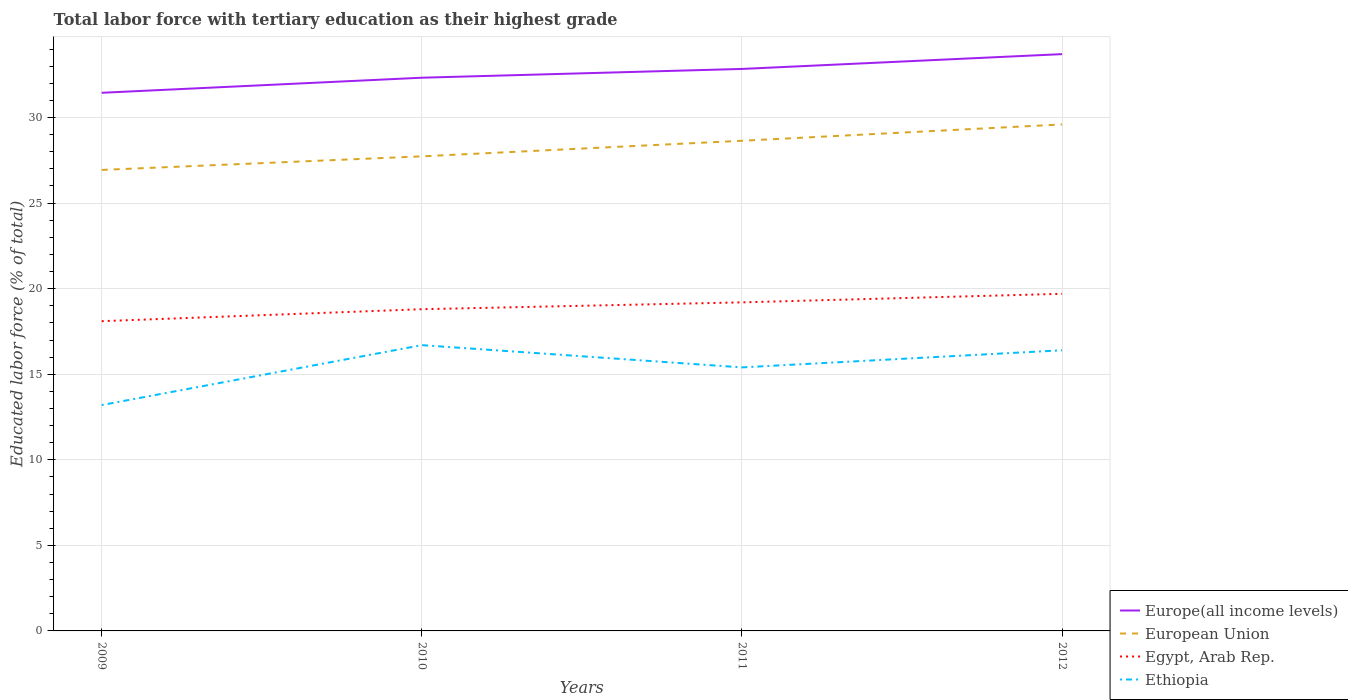How many different coloured lines are there?
Your answer should be very brief. 4. Is the number of lines equal to the number of legend labels?
Give a very brief answer. Yes. Across all years, what is the maximum percentage of male labor force with tertiary education in European Union?
Provide a succinct answer. 26.94. What is the total percentage of male labor force with tertiary education in Egypt, Arab Rep. in the graph?
Offer a terse response. -0.4. What is the difference between the highest and the second highest percentage of male labor force with tertiary education in European Union?
Give a very brief answer. 2.66. Is the percentage of male labor force with tertiary education in European Union strictly greater than the percentage of male labor force with tertiary education in Europe(all income levels) over the years?
Make the answer very short. Yes. How many years are there in the graph?
Offer a terse response. 4. Are the values on the major ticks of Y-axis written in scientific E-notation?
Offer a terse response. No. Does the graph contain grids?
Make the answer very short. Yes. What is the title of the graph?
Provide a short and direct response. Total labor force with tertiary education as their highest grade. What is the label or title of the Y-axis?
Your answer should be compact. Educated labor force (% of total). What is the Educated labor force (% of total) in Europe(all income levels) in 2009?
Keep it short and to the point. 31.45. What is the Educated labor force (% of total) of European Union in 2009?
Provide a succinct answer. 26.94. What is the Educated labor force (% of total) in Egypt, Arab Rep. in 2009?
Ensure brevity in your answer.  18.1. What is the Educated labor force (% of total) in Ethiopia in 2009?
Your response must be concise. 13.2. What is the Educated labor force (% of total) in Europe(all income levels) in 2010?
Keep it short and to the point. 32.33. What is the Educated labor force (% of total) in European Union in 2010?
Your answer should be compact. 27.73. What is the Educated labor force (% of total) in Egypt, Arab Rep. in 2010?
Your answer should be compact. 18.8. What is the Educated labor force (% of total) in Ethiopia in 2010?
Give a very brief answer. 16.7. What is the Educated labor force (% of total) of Europe(all income levels) in 2011?
Keep it short and to the point. 32.84. What is the Educated labor force (% of total) of European Union in 2011?
Make the answer very short. 28.64. What is the Educated labor force (% of total) in Egypt, Arab Rep. in 2011?
Offer a very short reply. 19.2. What is the Educated labor force (% of total) of Ethiopia in 2011?
Your answer should be very brief. 15.4. What is the Educated labor force (% of total) in Europe(all income levels) in 2012?
Make the answer very short. 33.71. What is the Educated labor force (% of total) in European Union in 2012?
Offer a terse response. 29.6. What is the Educated labor force (% of total) in Egypt, Arab Rep. in 2012?
Make the answer very short. 19.7. What is the Educated labor force (% of total) of Ethiopia in 2012?
Keep it short and to the point. 16.4. Across all years, what is the maximum Educated labor force (% of total) of Europe(all income levels)?
Your answer should be very brief. 33.71. Across all years, what is the maximum Educated labor force (% of total) of European Union?
Your response must be concise. 29.6. Across all years, what is the maximum Educated labor force (% of total) in Egypt, Arab Rep.?
Give a very brief answer. 19.7. Across all years, what is the maximum Educated labor force (% of total) in Ethiopia?
Your answer should be compact. 16.7. Across all years, what is the minimum Educated labor force (% of total) of Europe(all income levels)?
Provide a succinct answer. 31.45. Across all years, what is the minimum Educated labor force (% of total) of European Union?
Provide a short and direct response. 26.94. Across all years, what is the minimum Educated labor force (% of total) in Egypt, Arab Rep.?
Give a very brief answer. 18.1. Across all years, what is the minimum Educated labor force (% of total) in Ethiopia?
Offer a very short reply. 13.2. What is the total Educated labor force (% of total) in Europe(all income levels) in the graph?
Provide a succinct answer. 130.32. What is the total Educated labor force (% of total) of European Union in the graph?
Your answer should be very brief. 112.91. What is the total Educated labor force (% of total) in Egypt, Arab Rep. in the graph?
Provide a succinct answer. 75.8. What is the total Educated labor force (% of total) in Ethiopia in the graph?
Give a very brief answer. 61.7. What is the difference between the Educated labor force (% of total) in Europe(all income levels) in 2009 and that in 2010?
Your answer should be compact. -0.88. What is the difference between the Educated labor force (% of total) of European Union in 2009 and that in 2010?
Ensure brevity in your answer.  -0.79. What is the difference between the Educated labor force (% of total) of Egypt, Arab Rep. in 2009 and that in 2010?
Your answer should be very brief. -0.7. What is the difference between the Educated labor force (% of total) in Europe(all income levels) in 2009 and that in 2011?
Offer a terse response. -1.39. What is the difference between the Educated labor force (% of total) in European Union in 2009 and that in 2011?
Give a very brief answer. -1.7. What is the difference between the Educated labor force (% of total) of Egypt, Arab Rep. in 2009 and that in 2011?
Provide a succinct answer. -1.1. What is the difference between the Educated labor force (% of total) of Europe(all income levels) in 2009 and that in 2012?
Provide a short and direct response. -2.26. What is the difference between the Educated labor force (% of total) of European Union in 2009 and that in 2012?
Make the answer very short. -2.66. What is the difference between the Educated labor force (% of total) in Egypt, Arab Rep. in 2009 and that in 2012?
Make the answer very short. -1.6. What is the difference between the Educated labor force (% of total) in Europe(all income levels) in 2010 and that in 2011?
Keep it short and to the point. -0.51. What is the difference between the Educated labor force (% of total) in European Union in 2010 and that in 2011?
Provide a short and direct response. -0.91. What is the difference between the Educated labor force (% of total) of Egypt, Arab Rep. in 2010 and that in 2011?
Provide a short and direct response. -0.4. What is the difference between the Educated labor force (% of total) in Europe(all income levels) in 2010 and that in 2012?
Offer a terse response. -1.38. What is the difference between the Educated labor force (% of total) of European Union in 2010 and that in 2012?
Your answer should be compact. -1.86. What is the difference between the Educated labor force (% of total) of Egypt, Arab Rep. in 2010 and that in 2012?
Keep it short and to the point. -0.9. What is the difference between the Educated labor force (% of total) of Europe(all income levels) in 2011 and that in 2012?
Provide a succinct answer. -0.87. What is the difference between the Educated labor force (% of total) of European Union in 2011 and that in 2012?
Offer a very short reply. -0.95. What is the difference between the Educated labor force (% of total) of Ethiopia in 2011 and that in 2012?
Ensure brevity in your answer.  -1. What is the difference between the Educated labor force (% of total) in Europe(all income levels) in 2009 and the Educated labor force (% of total) in European Union in 2010?
Provide a short and direct response. 3.71. What is the difference between the Educated labor force (% of total) in Europe(all income levels) in 2009 and the Educated labor force (% of total) in Egypt, Arab Rep. in 2010?
Your response must be concise. 12.65. What is the difference between the Educated labor force (% of total) of Europe(all income levels) in 2009 and the Educated labor force (% of total) of Ethiopia in 2010?
Your response must be concise. 14.75. What is the difference between the Educated labor force (% of total) of European Union in 2009 and the Educated labor force (% of total) of Egypt, Arab Rep. in 2010?
Provide a succinct answer. 8.14. What is the difference between the Educated labor force (% of total) in European Union in 2009 and the Educated labor force (% of total) in Ethiopia in 2010?
Provide a succinct answer. 10.24. What is the difference between the Educated labor force (% of total) of Europe(all income levels) in 2009 and the Educated labor force (% of total) of European Union in 2011?
Give a very brief answer. 2.8. What is the difference between the Educated labor force (% of total) of Europe(all income levels) in 2009 and the Educated labor force (% of total) of Egypt, Arab Rep. in 2011?
Make the answer very short. 12.25. What is the difference between the Educated labor force (% of total) of Europe(all income levels) in 2009 and the Educated labor force (% of total) of Ethiopia in 2011?
Your answer should be compact. 16.05. What is the difference between the Educated labor force (% of total) of European Union in 2009 and the Educated labor force (% of total) of Egypt, Arab Rep. in 2011?
Offer a very short reply. 7.74. What is the difference between the Educated labor force (% of total) of European Union in 2009 and the Educated labor force (% of total) of Ethiopia in 2011?
Keep it short and to the point. 11.54. What is the difference between the Educated labor force (% of total) in Europe(all income levels) in 2009 and the Educated labor force (% of total) in European Union in 2012?
Offer a terse response. 1.85. What is the difference between the Educated labor force (% of total) in Europe(all income levels) in 2009 and the Educated labor force (% of total) in Egypt, Arab Rep. in 2012?
Keep it short and to the point. 11.75. What is the difference between the Educated labor force (% of total) in Europe(all income levels) in 2009 and the Educated labor force (% of total) in Ethiopia in 2012?
Make the answer very short. 15.05. What is the difference between the Educated labor force (% of total) of European Union in 2009 and the Educated labor force (% of total) of Egypt, Arab Rep. in 2012?
Make the answer very short. 7.24. What is the difference between the Educated labor force (% of total) in European Union in 2009 and the Educated labor force (% of total) in Ethiopia in 2012?
Give a very brief answer. 10.54. What is the difference between the Educated labor force (% of total) of Europe(all income levels) in 2010 and the Educated labor force (% of total) of European Union in 2011?
Offer a very short reply. 3.68. What is the difference between the Educated labor force (% of total) of Europe(all income levels) in 2010 and the Educated labor force (% of total) of Egypt, Arab Rep. in 2011?
Offer a terse response. 13.13. What is the difference between the Educated labor force (% of total) in Europe(all income levels) in 2010 and the Educated labor force (% of total) in Ethiopia in 2011?
Ensure brevity in your answer.  16.93. What is the difference between the Educated labor force (% of total) of European Union in 2010 and the Educated labor force (% of total) of Egypt, Arab Rep. in 2011?
Ensure brevity in your answer.  8.53. What is the difference between the Educated labor force (% of total) of European Union in 2010 and the Educated labor force (% of total) of Ethiopia in 2011?
Ensure brevity in your answer.  12.33. What is the difference between the Educated labor force (% of total) of Egypt, Arab Rep. in 2010 and the Educated labor force (% of total) of Ethiopia in 2011?
Offer a terse response. 3.4. What is the difference between the Educated labor force (% of total) in Europe(all income levels) in 2010 and the Educated labor force (% of total) in European Union in 2012?
Your answer should be compact. 2.73. What is the difference between the Educated labor force (% of total) in Europe(all income levels) in 2010 and the Educated labor force (% of total) in Egypt, Arab Rep. in 2012?
Offer a terse response. 12.63. What is the difference between the Educated labor force (% of total) of Europe(all income levels) in 2010 and the Educated labor force (% of total) of Ethiopia in 2012?
Your answer should be very brief. 15.93. What is the difference between the Educated labor force (% of total) of European Union in 2010 and the Educated labor force (% of total) of Egypt, Arab Rep. in 2012?
Offer a very short reply. 8.03. What is the difference between the Educated labor force (% of total) of European Union in 2010 and the Educated labor force (% of total) of Ethiopia in 2012?
Give a very brief answer. 11.33. What is the difference between the Educated labor force (% of total) of Egypt, Arab Rep. in 2010 and the Educated labor force (% of total) of Ethiopia in 2012?
Offer a very short reply. 2.4. What is the difference between the Educated labor force (% of total) in Europe(all income levels) in 2011 and the Educated labor force (% of total) in European Union in 2012?
Offer a terse response. 3.24. What is the difference between the Educated labor force (% of total) of Europe(all income levels) in 2011 and the Educated labor force (% of total) of Egypt, Arab Rep. in 2012?
Ensure brevity in your answer.  13.14. What is the difference between the Educated labor force (% of total) in Europe(all income levels) in 2011 and the Educated labor force (% of total) in Ethiopia in 2012?
Your response must be concise. 16.44. What is the difference between the Educated labor force (% of total) of European Union in 2011 and the Educated labor force (% of total) of Egypt, Arab Rep. in 2012?
Your answer should be very brief. 8.94. What is the difference between the Educated labor force (% of total) of European Union in 2011 and the Educated labor force (% of total) of Ethiopia in 2012?
Your answer should be compact. 12.24. What is the difference between the Educated labor force (% of total) in Egypt, Arab Rep. in 2011 and the Educated labor force (% of total) in Ethiopia in 2012?
Give a very brief answer. 2.8. What is the average Educated labor force (% of total) in Europe(all income levels) per year?
Your answer should be very brief. 32.58. What is the average Educated labor force (% of total) of European Union per year?
Provide a succinct answer. 28.23. What is the average Educated labor force (% of total) in Egypt, Arab Rep. per year?
Offer a very short reply. 18.95. What is the average Educated labor force (% of total) of Ethiopia per year?
Keep it short and to the point. 15.43. In the year 2009, what is the difference between the Educated labor force (% of total) of Europe(all income levels) and Educated labor force (% of total) of European Union?
Provide a short and direct response. 4.51. In the year 2009, what is the difference between the Educated labor force (% of total) of Europe(all income levels) and Educated labor force (% of total) of Egypt, Arab Rep.?
Offer a terse response. 13.35. In the year 2009, what is the difference between the Educated labor force (% of total) in Europe(all income levels) and Educated labor force (% of total) in Ethiopia?
Provide a succinct answer. 18.25. In the year 2009, what is the difference between the Educated labor force (% of total) in European Union and Educated labor force (% of total) in Egypt, Arab Rep.?
Ensure brevity in your answer.  8.84. In the year 2009, what is the difference between the Educated labor force (% of total) in European Union and Educated labor force (% of total) in Ethiopia?
Your response must be concise. 13.74. In the year 2010, what is the difference between the Educated labor force (% of total) in Europe(all income levels) and Educated labor force (% of total) in European Union?
Ensure brevity in your answer.  4.59. In the year 2010, what is the difference between the Educated labor force (% of total) of Europe(all income levels) and Educated labor force (% of total) of Egypt, Arab Rep.?
Offer a very short reply. 13.53. In the year 2010, what is the difference between the Educated labor force (% of total) in Europe(all income levels) and Educated labor force (% of total) in Ethiopia?
Make the answer very short. 15.63. In the year 2010, what is the difference between the Educated labor force (% of total) in European Union and Educated labor force (% of total) in Egypt, Arab Rep.?
Keep it short and to the point. 8.93. In the year 2010, what is the difference between the Educated labor force (% of total) in European Union and Educated labor force (% of total) in Ethiopia?
Your answer should be very brief. 11.03. In the year 2011, what is the difference between the Educated labor force (% of total) of Europe(all income levels) and Educated labor force (% of total) of European Union?
Keep it short and to the point. 4.2. In the year 2011, what is the difference between the Educated labor force (% of total) in Europe(all income levels) and Educated labor force (% of total) in Egypt, Arab Rep.?
Provide a short and direct response. 13.64. In the year 2011, what is the difference between the Educated labor force (% of total) in Europe(all income levels) and Educated labor force (% of total) in Ethiopia?
Ensure brevity in your answer.  17.44. In the year 2011, what is the difference between the Educated labor force (% of total) in European Union and Educated labor force (% of total) in Egypt, Arab Rep.?
Your answer should be compact. 9.44. In the year 2011, what is the difference between the Educated labor force (% of total) of European Union and Educated labor force (% of total) of Ethiopia?
Your answer should be very brief. 13.24. In the year 2012, what is the difference between the Educated labor force (% of total) in Europe(all income levels) and Educated labor force (% of total) in European Union?
Offer a terse response. 4.11. In the year 2012, what is the difference between the Educated labor force (% of total) in Europe(all income levels) and Educated labor force (% of total) in Egypt, Arab Rep.?
Your answer should be compact. 14.01. In the year 2012, what is the difference between the Educated labor force (% of total) of Europe(all income levels) and Educated labor force (% of total) of Ethiopia?
Your answer should be compact. 17.31. In the year 2012, what is the difference between the Educated labor force (% of total) of European Union and Educated labor force (% of total) of Egypt, Arab Rep.?
Ensure brevity in your answer.  9.9. In the year 2012, what is the difference between the Educated labor force (% of total) of European Union and Educated labor force (% of total) of Ethiopia?
Give a very brief answer. 13.2. What is the ratio of the Educated labor force (% of total) in Europe(all income levels) in 2009 to that in 2010?
Your answer should be compact. 0.97. What is the ratio of the Educated labor force (% of total) in European Union in 2009 to that in 2010?
Your answer should be compact. 0.97. What is the ratio of the Educated labor force (% of total) in Egypt, Arab Rep. in 2009 to that in 2010?
Provide a succinct answer. 0.96. What is the ratio of the Educated labor force (% of total) of Ethiopia in 2009 to that in 2010?
Give a very brief answer. 0.79. What is the ratio of the Educated labor force (% of total) of Europe(all income levels) in 2009 to that in 2011?
Give a very brief answer. 0.96. What is the ratio of the Educated labor force (% of total) in European Union in 2009 to that in 2011?
Offer a very short reply. 0.94. What is the ratio of the Educated labor force (% of total) in Egypt, Arab Rep. in 2009 to that in 2011?
Make the answer very short. 0.94. What is the ratio of the Educated labor force (% of total) in Europe(all income levels) in 2009 to that in 2012?
Make the answer very short. 0.93. What is the ratio of the Educated labor force (% of total) in European Union in 2009 to that in 2012?
Offer a terse response. 0.91. What is the ratio of the Educated labor force (% of total) of Egypt, Arab Rep. in 2009 to that in 2012?
Make the answer very short. 0.92. What is the ratio of the Educated labor force (% of total) of Ethiopia in 2009 to that in 2012?
Offer a very short reply. 0.8. What is the ratio of the Educated labor force (% of total) in Europe(all income levels) in 2010 to that in 2011?
Give a very brief answer. 0.98. What is the ratio of the Educated labor force (% of total) of European Union in 2010 to that in 2011?
Offer a very short reply. 0.97. What is the ratio of the Educated labor force (% of total) in Egypt, Arab Rep. in 2010 to that in 2011?
Keep it short and to the point. 0.98. What is the ratio of the Educated labor force (% of total) of Ethiopia in 2010 to that in 2011?
Provide a short and direct response. 1.08. What is the ratio of the Educated labor force (% of total) in Europe(all income levels) in 2010 to that in 2012?
Provide a succinct answer. 0.96. What is the ratio of the Educated labor force (% of total) of European Union in 2010 to that in 2012?
Offer a very short reply. 0.94. What is the ratio of the Educated labor force (% of total) of Egypt, Arab Rep. in 2010 to that in 2012?
Your answer should be very brief. 0.95. What is the ratio of the Educated labor force (% of total) in Ethiopia in 2010 to that in 2012?
Give a very brief answer. 1.02. What is the ratio of the Educated labor force (% of total) of Europe(all income levels) in 2011 to that in 2012?
Provide a succinct answer. 0.97. What is the ratio of the Educated labor force (% of total) of European Union in 2011 to that in 2012?
Ensure brevity in your answer.  0.97. What is the ratio of the Educated labor force (% of total) of Egypt, Arab Rep. in 2011 to that in 2012?
Your answer should be very brief. 0.97. What is the ratio of the Educated labor force (% of total) of Ethiopia in 2011 to that in 2012?
Give a very brief answer. 0.94. What is the difference between the highest and the second highest Educated labor force (% of total) of Europe(all income levels)?
Your answer should be very brief. 0.87. What is the difference between the highest and the second highest Educated labor force (% of total) of European Union?
Provide a short and direct response. 0.95. What is the difference between the highest and the lowest Educated labor force (% of total) of Europe(all income levels)?
Make the answer very short. 2.26. What is the difference between the highest and the lowest Educated labor force (% of total) in European Union?
Your answer should be very brief. 2.66. What is the difference between the highest and the lowest Educated labor force (% of total) in Egypt, Arab Rep.?
Your answer should be very brief. 1.6. 